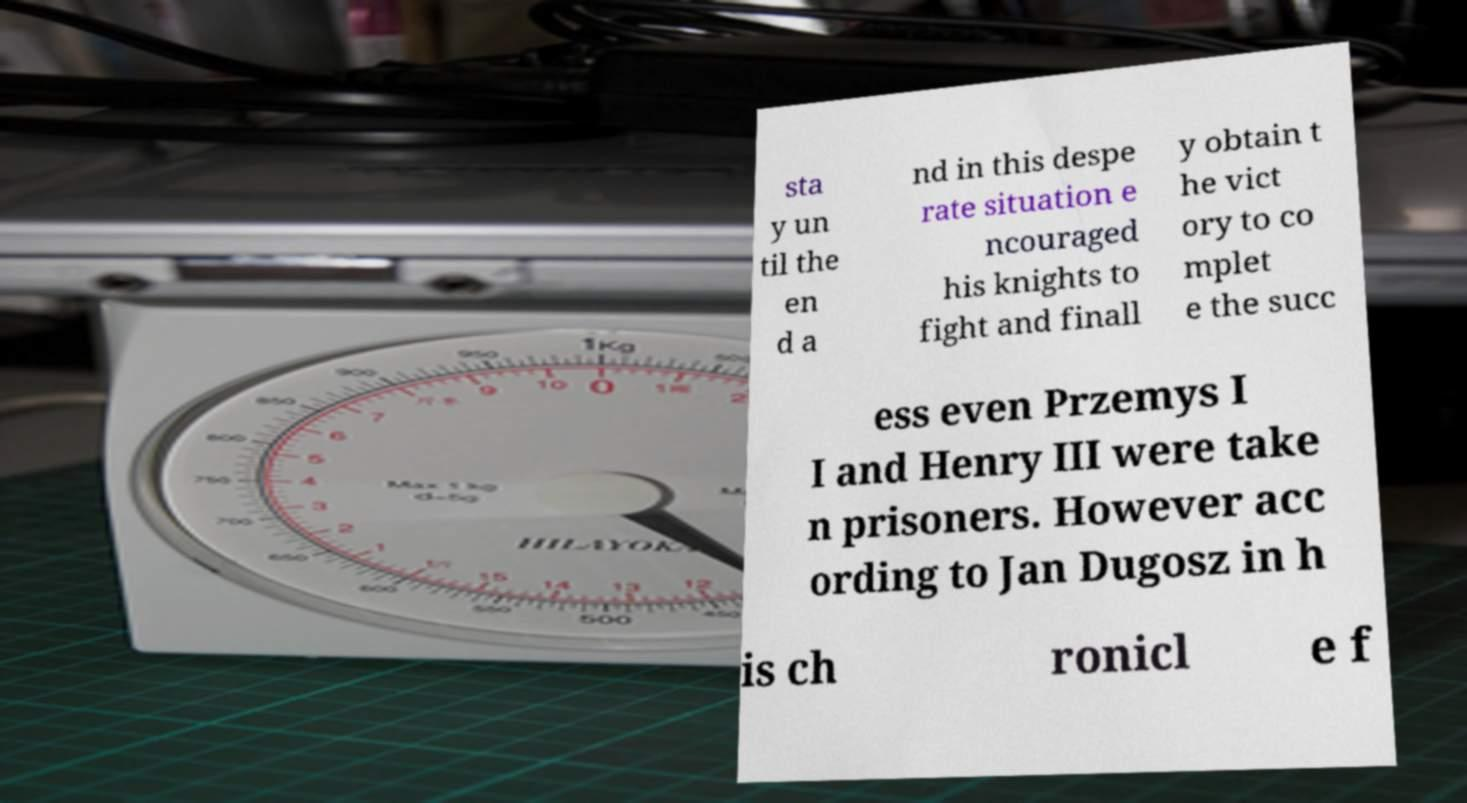Can you read and provide the text displayed in the image?This photo seems to have some interesting text. Can you extract and type it out for me? sta y un til the en d a nd in this despe rate situation e ncouraged his knights to fight and finall y obtain t he vict ory to co mplet e the succ ess even Przemys I I and Henry III were take n prisoners. However acc ording to Jan Dugosz in h is ch ronicl e f 